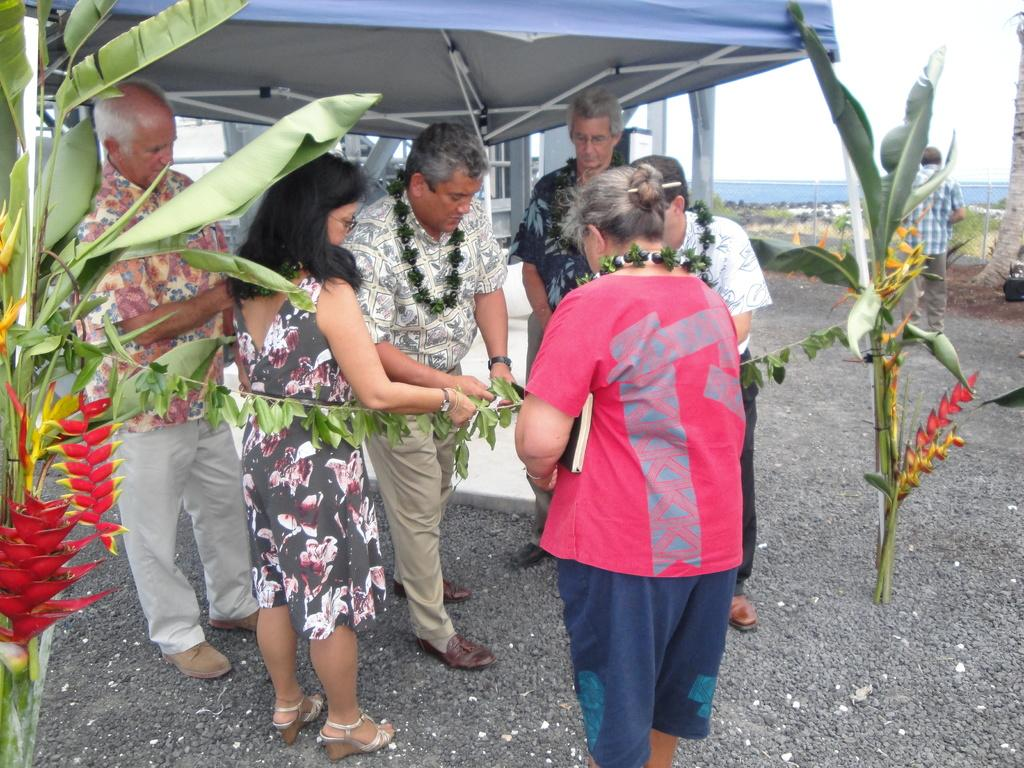What are the people in the image doing? The people in the image are standing. What are some of the people wearing? Some of the people are wearing garlands. What type of vegetation can be seen in the image? There are trees in the image. What is visible in the background of the image? There is a tent and the sky visible in the background of the image. What type of line can be seen on the table in the image? There is no table present in the image, so there is no line to be seen on it. 